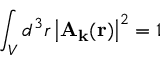Convert formula to latex. <formula><loc_0><loc_0><loc_500><loc_500>\int _ { V } d ^ { 3 } r \left | A _ { k } ( r ) \right | ^ { 2 } = 1</formula> 